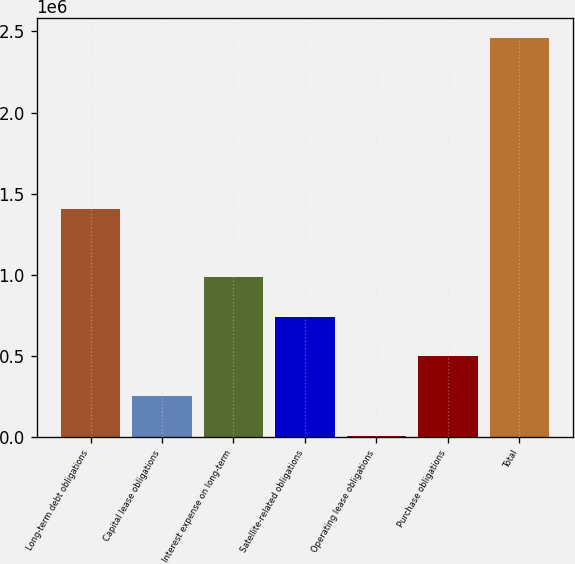Convert chart. <chart><loc_0><loc_0><loc_500><loc_500><bar_chart><fcel>Long-term debt obligations<fcel>Capital lease obligations<fcel>Interest expense on long-term<fcel>Satellite-related obligations<fcel>Operating lease obligations<fcel>Purchase obligations<fcel>Total<nl><fcel>1.4033e+06<fcel>252126<fcel>988400<fcel>742975<fcel>6702<fcel>497551<fcel>2.46095e+06<nl></chart> 